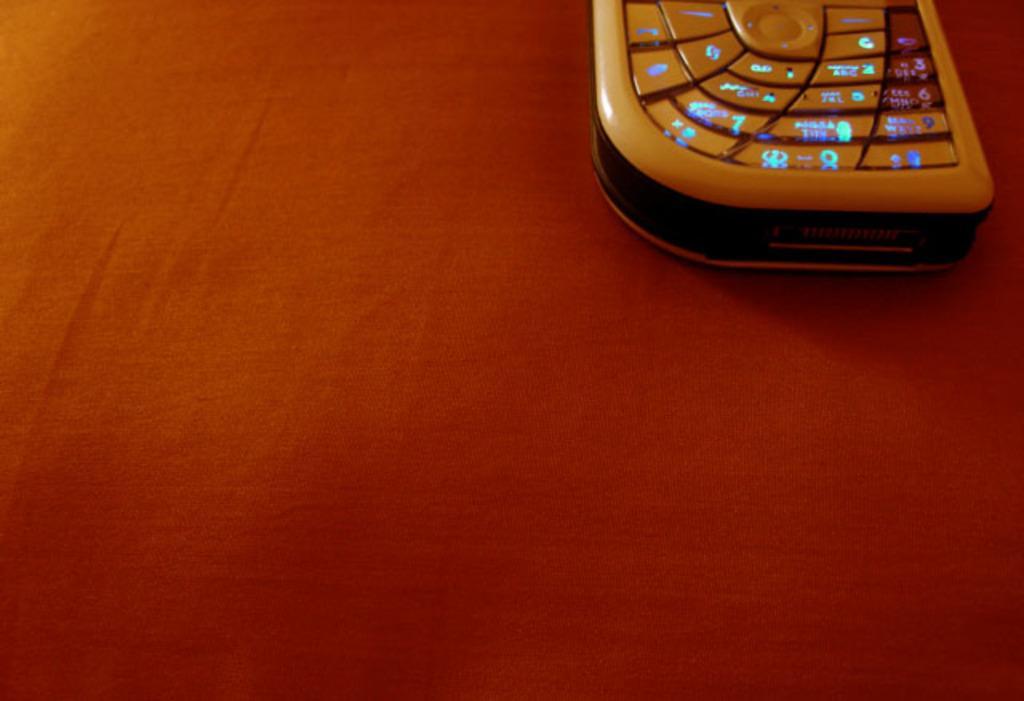In one or two sentences, can you explain what this image depicts? This image consists of a mobile is kept on a table. The table is covered with a red cloth. 